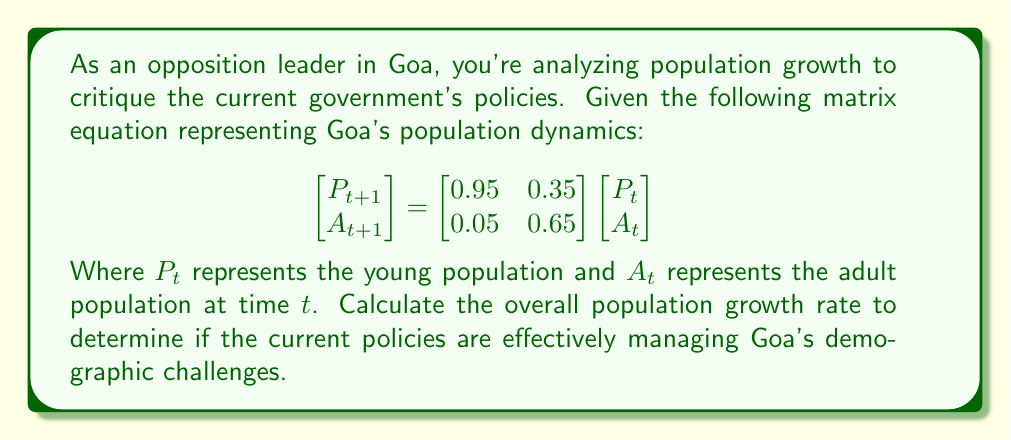Could you help me with this problem? To find the overall population growth rate, we need to:

1. Calculate the eigenvalues of the transition matrix:

$$M = \begin{bmatrix} 0.95 & 0.35 \\ 0.05 & 0.65 \end{bmatrix}$$

2. The characteristic equation is:
   $det(M - \lambda I) = 0$
   
   $\begin{vmatrix} 0.95 - \lambda & 0.35 \\ 0.05 & 0.65 - \lambda \end{vmatrix} = 0$
   
   $(0.95 - \lambda)(0.65 - \lambda) - 0.0175 = 0$
   
   $\lambda^2 - 1.6\lambda + 0.6 = 0$

3. Solving this quadratic equation:
   $\lambda = \frac{1.6 \pm \sqrt{1.6^2 - 4(0.6)}}{2} = \frac{1.6 \pm \sqrt{1.36}}{2}$
   
   $\lambda_1 = \frac{1.6 + 1.1662}{2} \approx 1.3831$
   $\lambda_2 = \frac{1.6 - 1.1662}{2} \approx 0.2169$

4. The dominant eigenvalue $\lambda_1 \approx 1.3831$ represents the long-term growth rate.

5. To convert this to a percentage growth rate:
   Growth rate = $(\lambda_1 - 1) \times 100\% \approx (1.3831 - 1) \times 100\% \approx 38.31\%$
Answer: 38.31% 